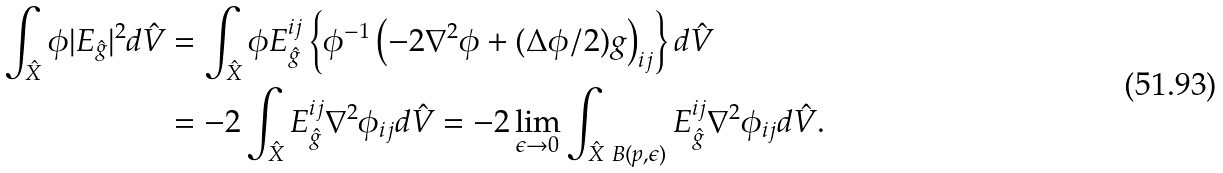<formula> <loc_0><loc_0><loc_500><loc_500>\int _ { \hat { X } } \phi | E _ { \hat { g } } | ^ { 2 } d \hat { V } & = \int _ { \hat { X } } \phi E _ { \hat { g } } ^ { i j } \left \{ \phi ^ { - 1 } \left ( - 2 \nabla ^ { 2 } \phi + ( \Delta \phi / 2 ) g \right ) _ { i j } \right \} d \hat { V } \\ & = - 2 \int _ { \hat { X } } E _ { \hat { g } } ^ { i j } \nabla ^ { 2 } \phi _ { i j } d \hat { V } = - 2 \lim _ { \epsilon \rightarrow 0 } \int _ { \hat { X } \ B ( p , \epsilon ) } E _ { \hat { g } } ^ { i j } \nabla ^ { 2 } \phi _ { i j } d \hat { V } .</formula> 